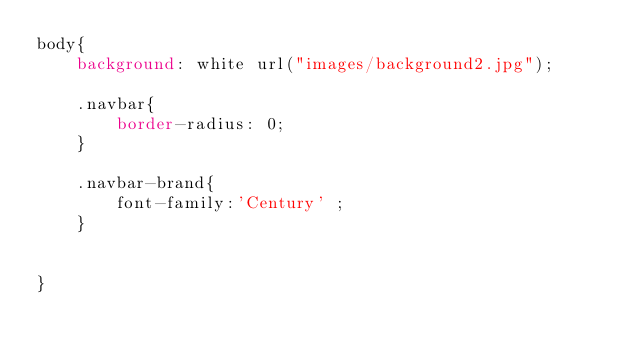<code> <loc_0><loc_0><loc_500><loc_500><_CSS_>body{
    background: white url("images/background2.jpg");

    .navbar{
        border-radius: 0;
    }

    .navbar-brand{
        font-family:'Century' ;
    }


}
</code> 